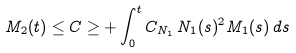<formula> <loc_0><loc_0><loc_500><loc_500>M _ { 2 } ( t ) \leq C \geq + \int _ { 0 } ^ { t } C _ { N _ { 1 } } \, N _ { 1 } ( s ) ^ { 2 } M _ { 1 } ( s ) \, d s</formula> 